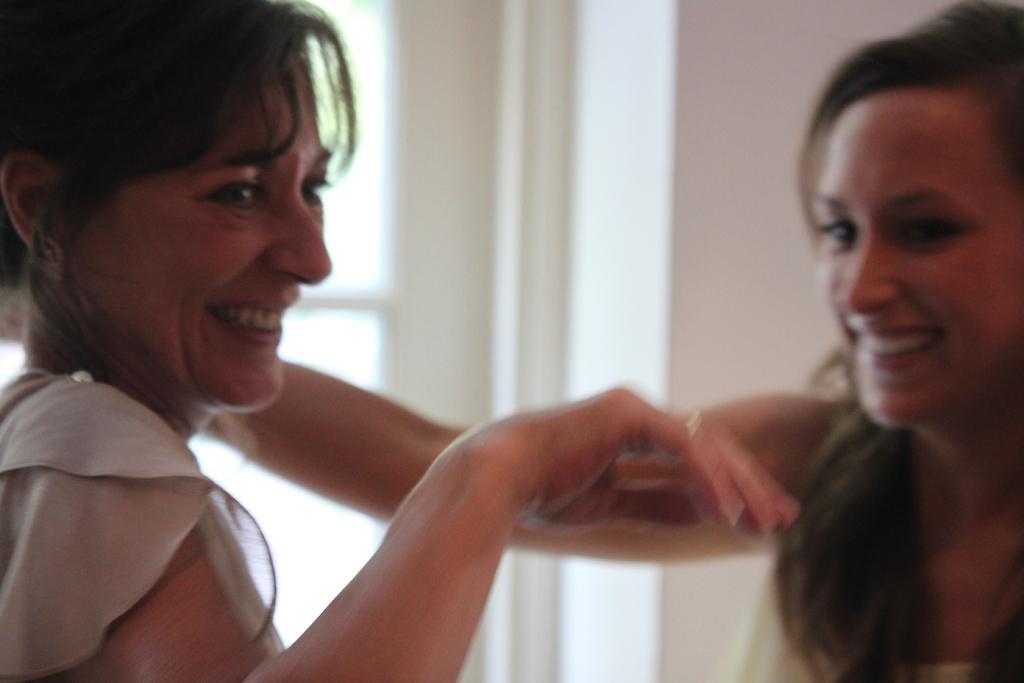Can you describe this image briefly? In the image two women are smiling. Behind them there is wall. 